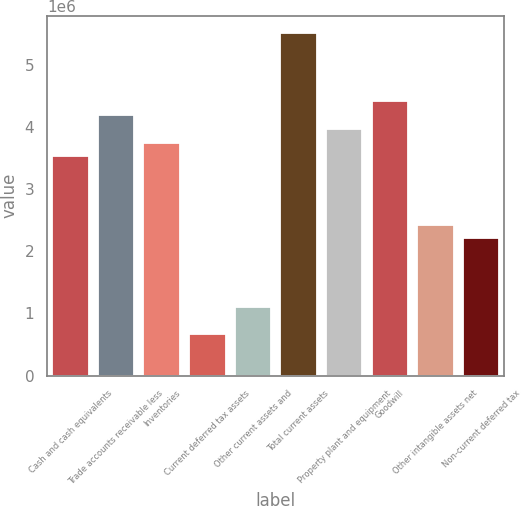Convert chart. <chart><loc_0><loc_0><loc_500><loc_500><bar_chart><fcel>Cash and cash equivalents<fcel>Trade accounts receivable less<fcel>Inventories<fcel>Current deferred tax assets<fcel>Other current assets and<fcel>Total current assets<fcel>Property plant and equipment<fcel>Goodwill<fcel>Other intangible assets net<fcel>Non-current deferred tax<nl><fcel>3.52529e+06<fcel>4.1862e+06<fcel>3.74559e+06<fcel>661356<fcel>1.10196e+06<fcel>5.50801e+06<fcel>3.96589e+06<fcel>4.4065e+06<fcel>2.42378e+06<fcel>2.20347e+06<nl></chart> 